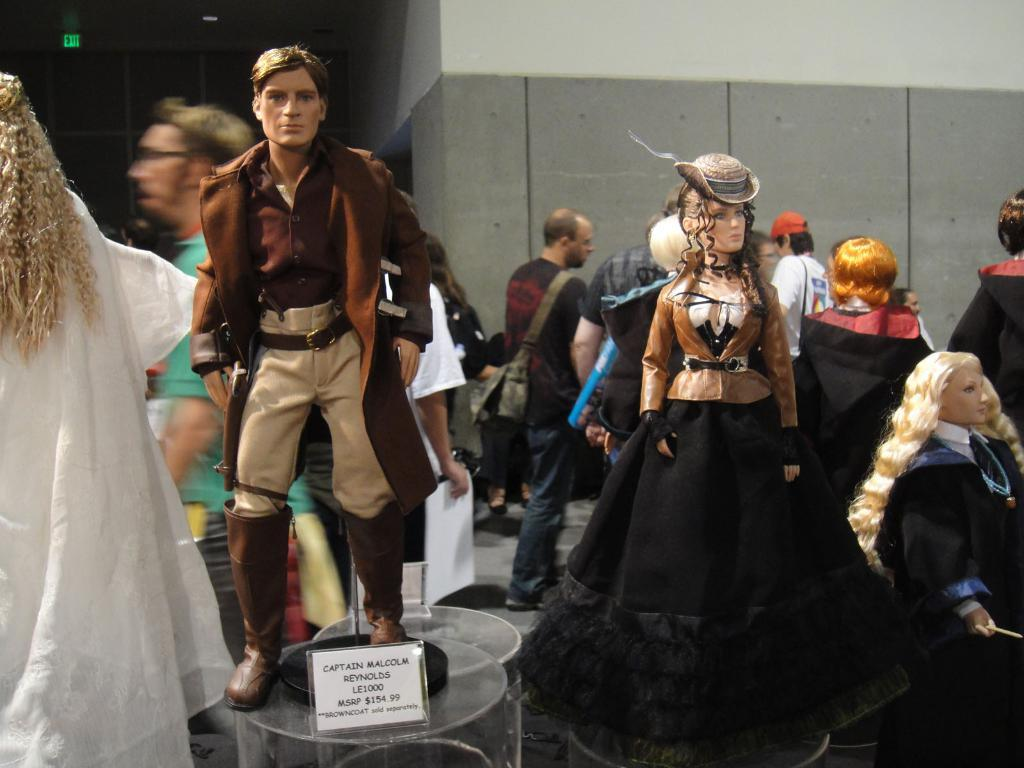What type of objects are on the table in the image? There are human toys on the table in the image. What are the toys wearing? The toys are wearing costumes. What can be seen in the background of the image? There are people standing on the footpath in the background. What type of body is visible in the image? There is no body present in the image; it features human toys wearing costumes on a table. How many crates are stacked on the table in the image? There are no crates present in the image. 